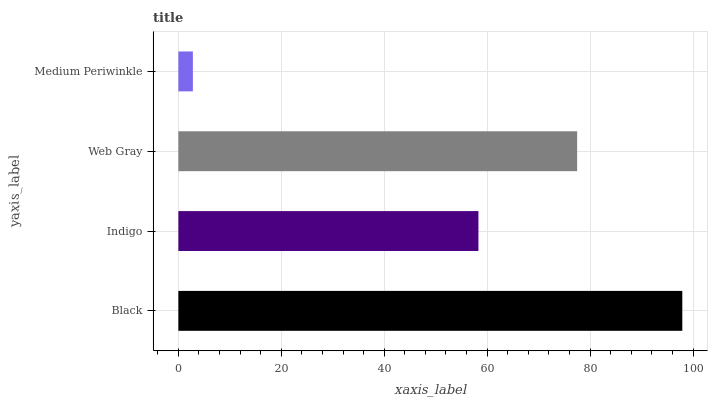Is Medium Periwinkle the minimum?
Answer yes or no. Yes. Is Black the maximum?
Answer yes or no. Yes. Is Indigo the minimum?
Answer yes or no. No. Is Indigo the maximum?
Answer yes or no. No. Is Black greater than Indigo?
Answer yes or no. Yes. Is Indigo less than Black?
Answer yes or no. Yes. Is Indigo greater than Black?
Answer yes or no. No. Is Black less than Indigo?
Answer yes or no. No. Is Web Gray the high median?
Answer yes or no. Yes. Is Indigo the low median?
Answer yes or no. Yes. Is Medium Periwinkle the high median?
Answer yes or no. No. Is Web Gray the low median?
Answer yes or no. No. 